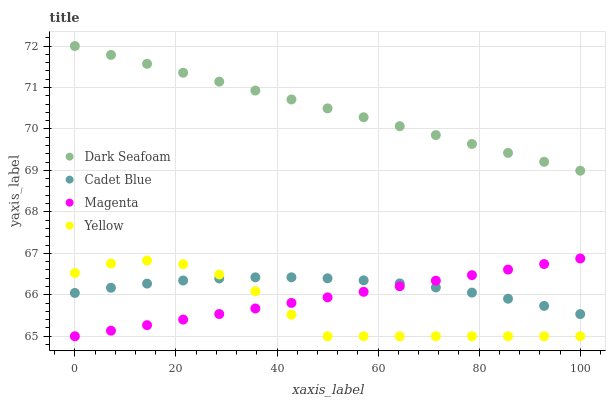Does Yellow have the minimum area under the curve?
Answer yes or no. Yes. Does Dark Seafoam have the maximum area under the curve?
Answer yes or no. Yes. Does Cadet Blue have the minimum area under the curve?
Answer yes or no. No. Does Cadet Blue have the maximum area under the curve?
Answer yes or no. No. Is Dark Seafoam the smoothest?
Answer yes or no. Yes. Is Yellow the roughest?
Answer yes or no. Yes. Is Cadet Blue the smoothest?
Answer yes or no. No. Is Cadet Blue the roughest?
Answer yes or no. No. Does Magenta have the lowest value?
Answer yes or no. Yes. Does Cadet Blue have the lowest value?
Answer yes or no. No. Does Dark Seafoam have the highest value?
Answer yes or no. Yes. Does Magenta have the highest value?
Answer yes or no. No. Is Cadet Blue less than Dark Seafoam?
Answer yes or no. Yes. Is Dark Seafoam greater than Cadet Blue?
Answer yes or no. Yes. Does Cadet Blue intersect Magenta?
Answer yes or no. Yes. Is Cadet Blue less than Magenta?
Answer yes or no. No. Is Cadet Blue greater than Magenta?
Answer yes or no. No. Does Cadet Blue intersect Dark Seafoam?
Answer yes or no. No. 